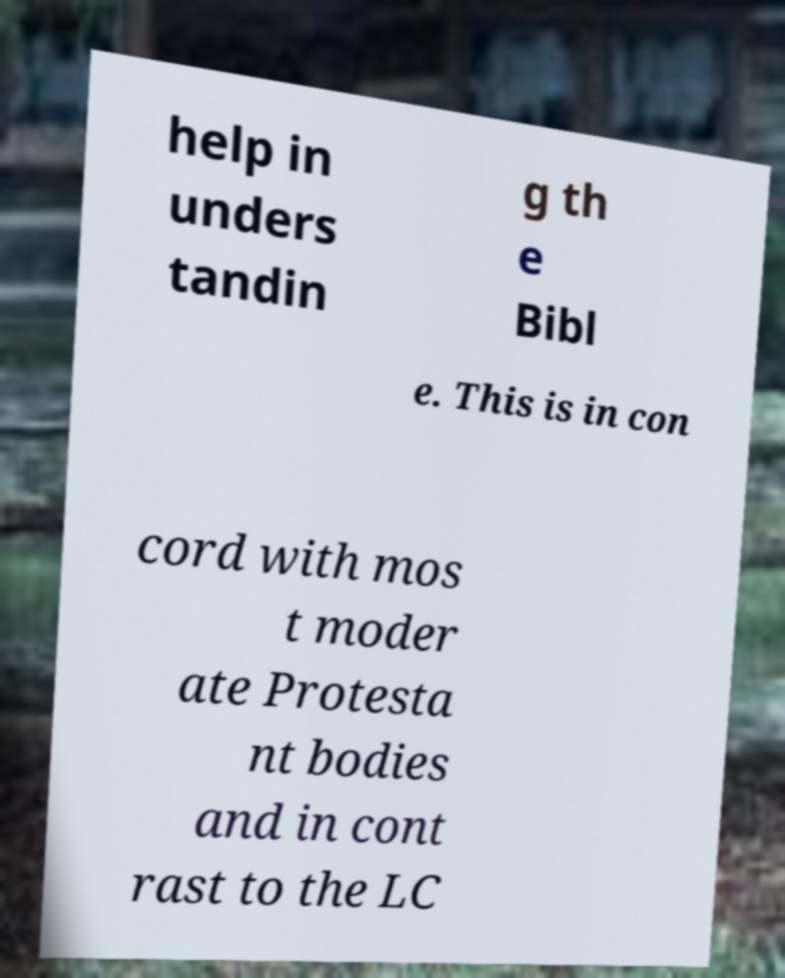What messages or text are displayed in this image? I need them in a readable, typed format. help in unders tandin g th e Bibl e. This is in con cord with mos t moder ate Protesta nt bodies and in cont rast to the LC 